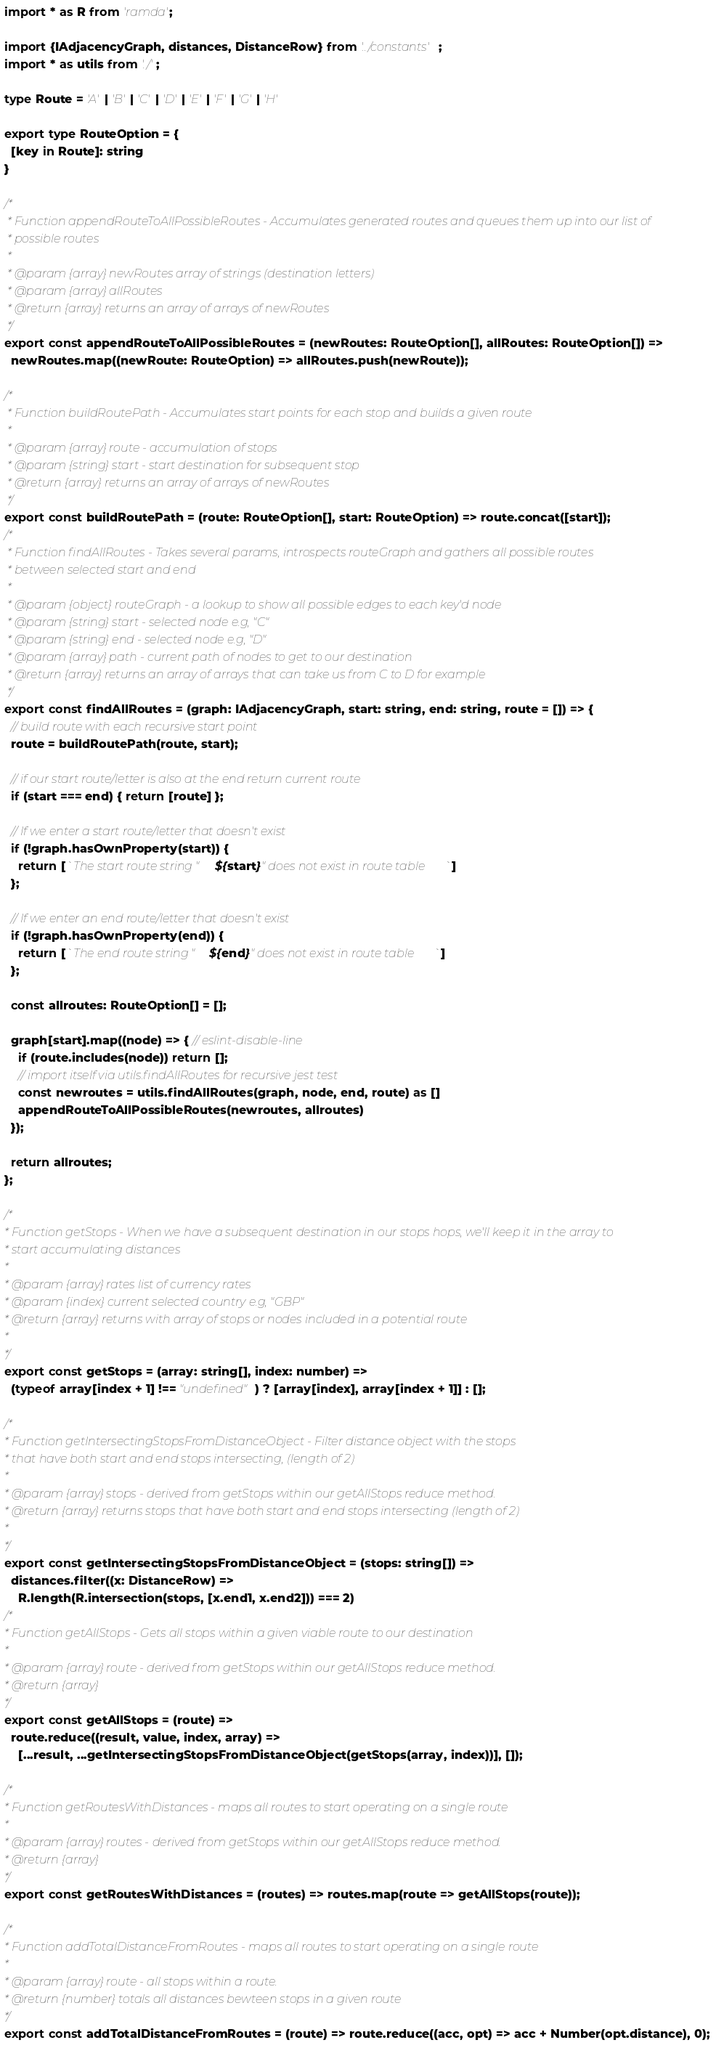<code> <loc_0><loc_0><loc_500><loc_500><_TypeScript_>import * as R from 'ramda';

import {IAdjacencyGraph, distances, DistanceRow} from '../constants';
import * as utils from './';

type Route = 'A' | 'B' | 'C' | 'D' | 'E' | 'F' | 'G' | 'H'

export type RouteOption = {
  [key in Route]: string
}

/*
 * Function appendRouteToAllPossibleRoutes - Accumulates generated routes and queues them up into our list of 
 * possible routes
 *
 * @param {array} newRoutes array of strings (destination letters)
 * @param {array} allRoutes
 * @return {array} returns an array of arrays of newRoutes
 */
export const appendRouteToAllPossibleRoutes = (newRoutes: RouteOption[], allRoutes: RouteOption[]) =>
  newRoutes.map((newRoute: RouteOption) => allRoutes.push(newRoute));

/*
 * Function buildRoutePath - Accumulates start points for each stop and builds a given route
 *
 * @param {array} route - accumulation of stops
 * @param {string} start - start destination for subsequent stop
 * @return {array} returns an array of arrays of newRoutes
 */
export const buildRoutePath = (route: RouteOption[], start: RouteOption) => route.concat([start]);
/*
 * Function findAllRoutes - Takes several params, introspects routeGraph and gathers all possible routes
 * between selected start and end
 *
 * @param {object} routeGraph - a lookup to show all possible edges to each key'd node
 * @param {string} start - selected node e.g, "C"
 * @param {string} end - selected node e.g, "D"
 * @param {array} path - current path of nodes to get to our destination
 * @return {array} returns an array of arrays that can take us from C to D for example
 */
export const findAllRoutes = (graph: IAdjacencyGraph, start: string, end: string, route = []) => {
  // build route with each recursive start point
  route = buildRoutePath(route, start);

  // if our start route/letter is also at the end return current route
  if (start === end) { return [route] };

  // If we enter a start route/letter that doesn't exist
  if (!graph.hasOwnProperty(start)) {
    return [`The start route string "${start}" does not exist in route table`]
  };

  // If we enter an end route/letter that doesn't exist
  if (!graph.hasOwnProperty(end)) {
    return [`The end route string "${end}" does not exist in route table`]
  };

  const allroutes: RouteOption[] = [];

  graph[start].map((node) => { // eslint-disable-line
    if (route.includes(node)) return [];
    // import itself via utils.findAllRoutes for recursive jest test
    const newroutes = utils.findAllRoutes(graph, node, end, route) as []
    appendRouteToAllPossibleRoutes(newroutes, allroutes)
  });

  return allroutes;
};

/*
* Function getStops - When we have a subsequent destination in our stops hops, we'll keep it in the array to
* start accumulating distances  
*
* @param {array} rates list of currency rates
* @param {index} current selected country e.g, "GBP"
* @return {array} returns with array of stops or nodes included in a potential route
*
*/
export const getStops = (array: string[], index: number) =>
  (typeof array[index + 1] !== "undefined") ? [array[index], array[index + 1]] : [];

/*
* Function getIntersectingStopsFromDistanceObject - Filter distance object with the stops
* that have both start and end stops intersecting, (length of 2)
*
* @param {array} stops - derived from getStops within our getAllStops reduce method. 
* @return {array} returns stops that have both start and end stops intersecting (length of 2)
*
*/
export const getIntersectingStopsFromDistanceObject = (stops: string[]) =>
  distances.filter((x: DistanceRow) =>
    R.length(R.intersection(stops, [x.end1, x.end2])) === 2)
/*
* Function getAllStops - Gets all stops within a given viable route to our destination
*
* @param {array} route - derived from getStops within our getAllStops reduce method. 
* @return {array}
*/
export const getAllStops = (route) =>
  route.reduce((result, value, index, array) =>
    [...result, ...getIntersectingStopsFromDistanceObject(getStops(array, index))], []);

/*
* Function getRoutesWithDistances - maps all routes to start operating on a single route
*
* @param {array} routes - derived from getStops within our getAllStops reduce method. 
* @return {array}
*/
export const getRoutesWithDistances = (routes) => routes.map(route => getAllStops(route));

/*
* Function addTotalDistanceFromRoutes - maps all routes to start operating on a single route
*
* @param {array} route - all stops within a route. 
* @return {number} totals all distances bewteen stops in a given route
*/
export const addTotalDistanceFromRoutes = (route) => route.reduce((acc, opt) => acc + Number(opt.distance), 0);
</code> 